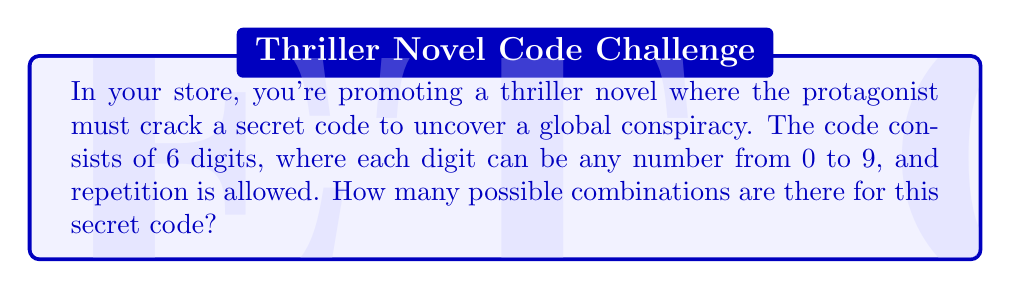Give your solution to this math problem. Let's approach this step-by-step:

1) We need to determine the number of choices for each position in the 6-digit code.

2) For each digit, we can use any number from 0 to 9. This means we have 10 choices for each position.

3) The code allows repetition, so we can use the same digit multiple times if needed.

4) In combinatorics, when we have a series of independent choices, we multiply the number of possibilities for each choice.

5) Since we have 6 positions, and each position has 10 possible choices, we can represent this mathematically as:

   $$10 \times 10 \times 10 \times 10 \times 10 \times 10$$

6) This can be written more concisely as:

   $$10^6$$

7) Calculating this:
   
   $$10^6 = 1,000,000$$

Therefore, there are 1,000,000 possible combinations for the secret code in the novel.
Answer: $10^6 = 1,000,000$ 